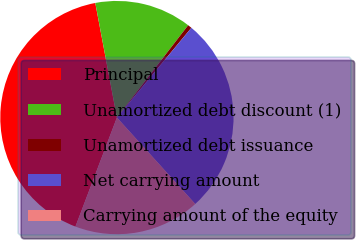Convert chart to OTSL. <chart><loc_0><loc_0><loc_500><loc_500><pie_chart><fcel>Principal<fcel>Unamortized debt discount (1)<fcel>Unamortized debt issuance<fcel>Net carrying amount<fcel>Carrying amount of the equity<nl><fcel>41.25%<fcel>13.43%<fcel>0.56%<fcel>27.26%<fcel>17.5%<nl></chart> 